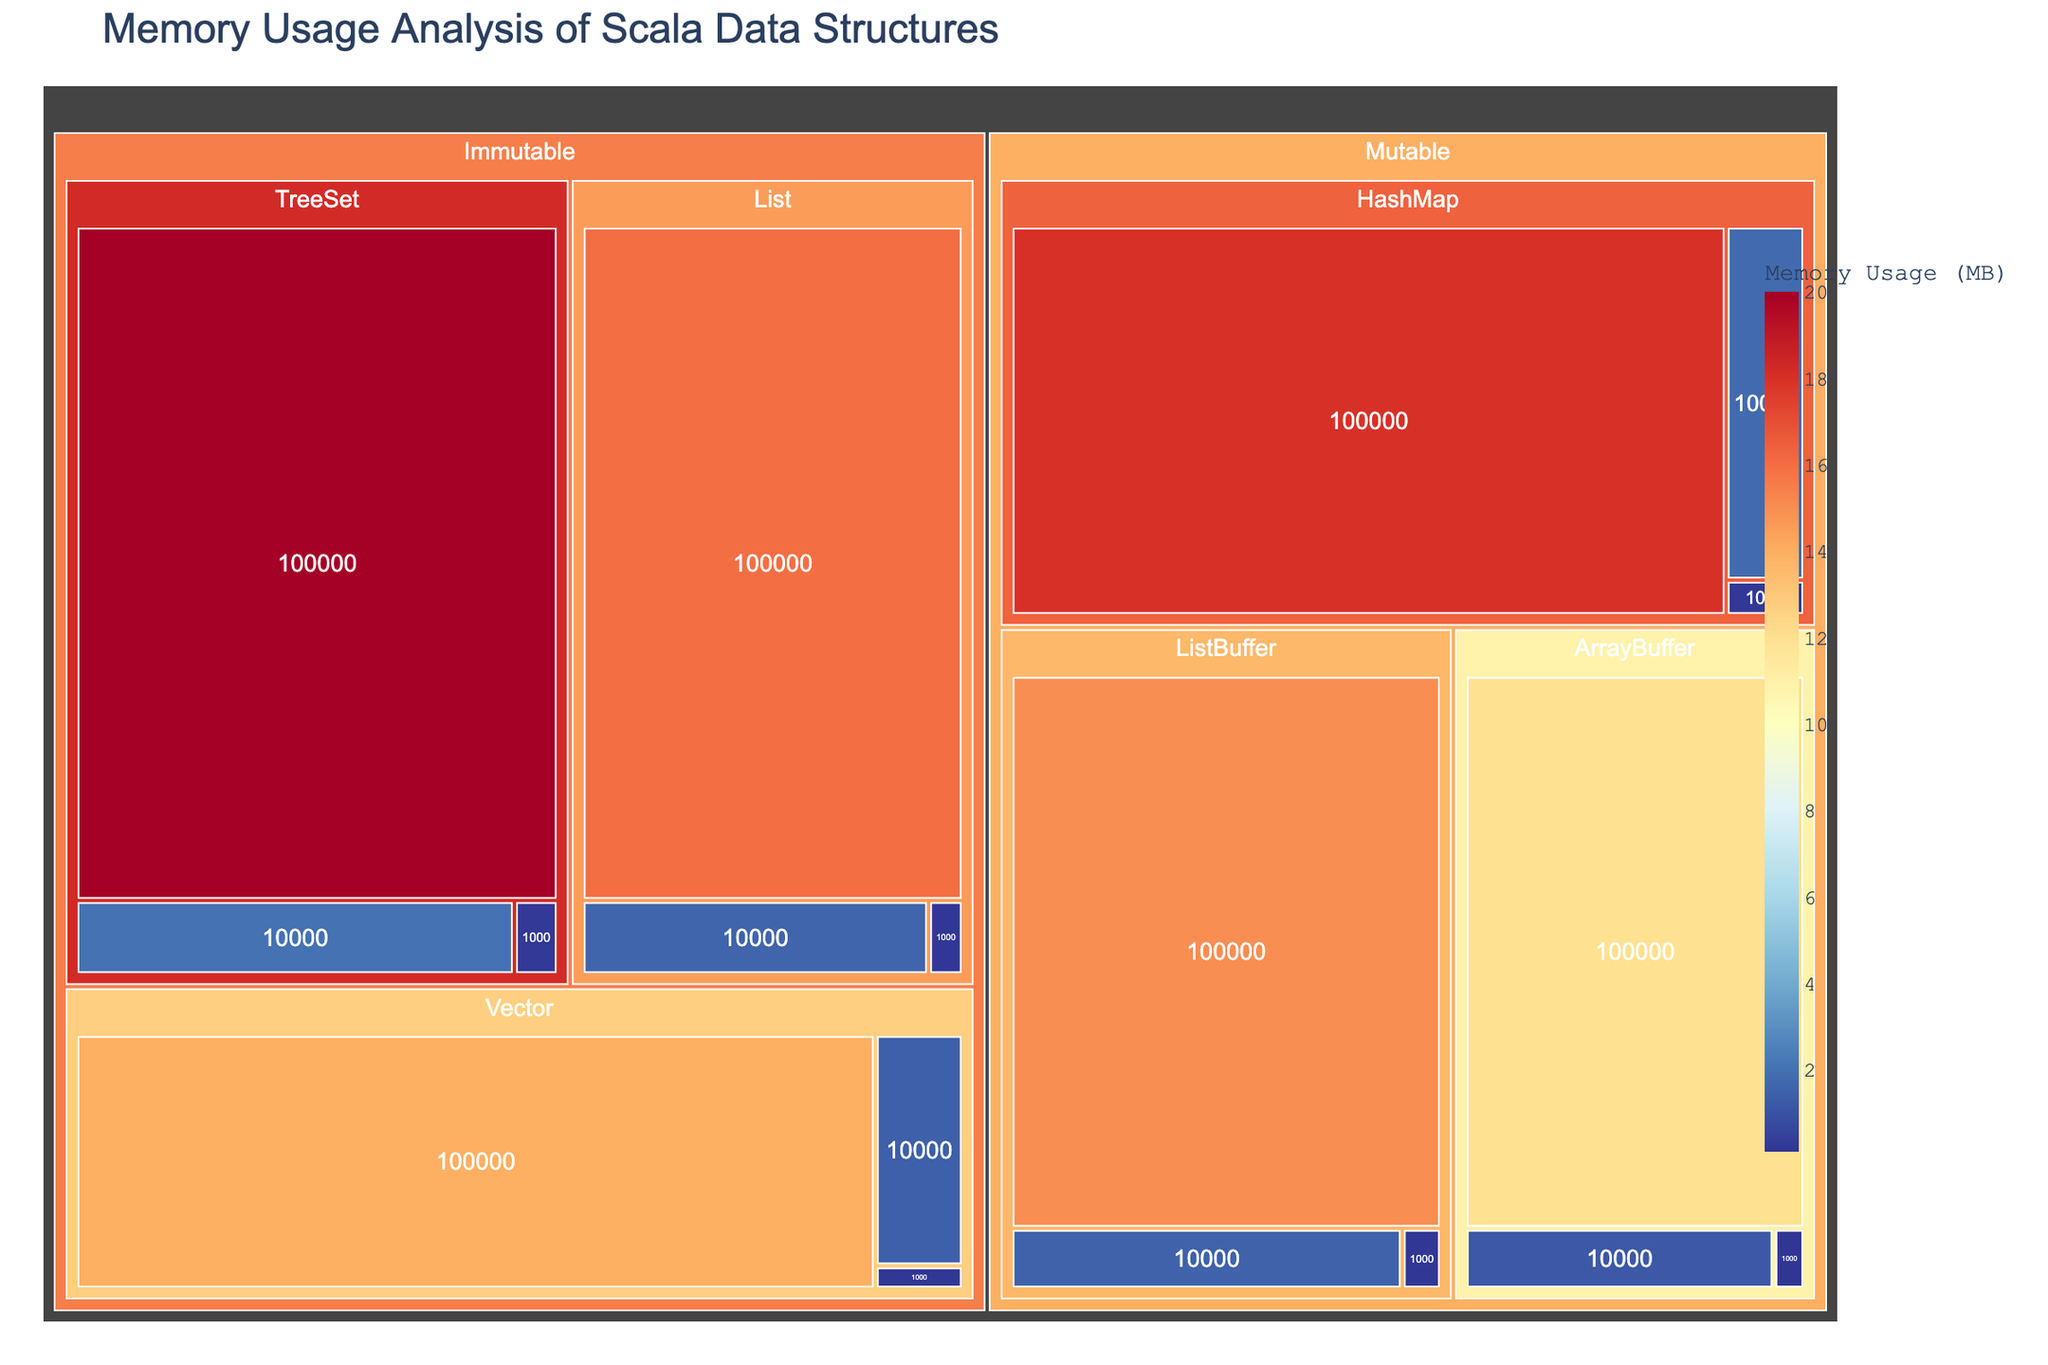How many collection types are there in the treemap? The treemap shows two main categories, "Mutable" and "Immutable," representing the two collection types.
Answer: 2 Which data structure within the Immutable collection type has the highest memory usage for a size of 100000? By examining the layout of the treemap, the "TreeSet" data structure appears to have the highest memory usage among the Immutable collection type for a size of 100000.
Answer: TreeSet What is the sum of memory usage for all data structures under Immutable collections for a size of 10000? The memory usages are: Vector (1.4), List (1.6), TreeSet (2.0). Thus, the sum is 1.4 + 1.6 + 2.0 = 5.
Answer: 5 MB Which Mutable data structure has a lower memory usage than ListBuffer for a size of 1000? For size 1000, "ArrayBuffer" (0.12 MB) and "HashMap" (0.18 MB) are the Mutable data structures. ListBuffer has 0.15 MB, so only ArrayBuffer (0.12 MB) has a lower memory usage.
Answer: ArrayBuffer Comparing sizes of 10000 and 100000, which collection type experiences the largest increase in TreeSet memory usage? For Immutable collection: TreeSet usage is 2.0 MB at 10000 and 20 MB at 100000. Increase = 20 - 2.0 = 18. For Mutable collection types, TreeSet does not exist. Thus, Immutable has the largest increase.
Answer: Immutable Which data structure has the lowest memory usage across all sizes in the Mutable collection type? Observing the data points, "ArrayBuffer" consistently has the lowest memory usage across all sizes in the Mutable collection type.
Answer: ArrayBuffer How does the memory usage of List in Immutable collections at a size of 1000 compare to ListBuffer in Mutable collections at the same size? List in Immutable collections uses 0.16 MB, while ListBuffer in Mutable collections uses 0.15 MB at the same size. 0.16 MB > 0.15 MB.
Answer: List (Immutable) has higher usage 